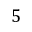<formula> <loc_0><loc_0><loc_500><loc_500>5</formula> 